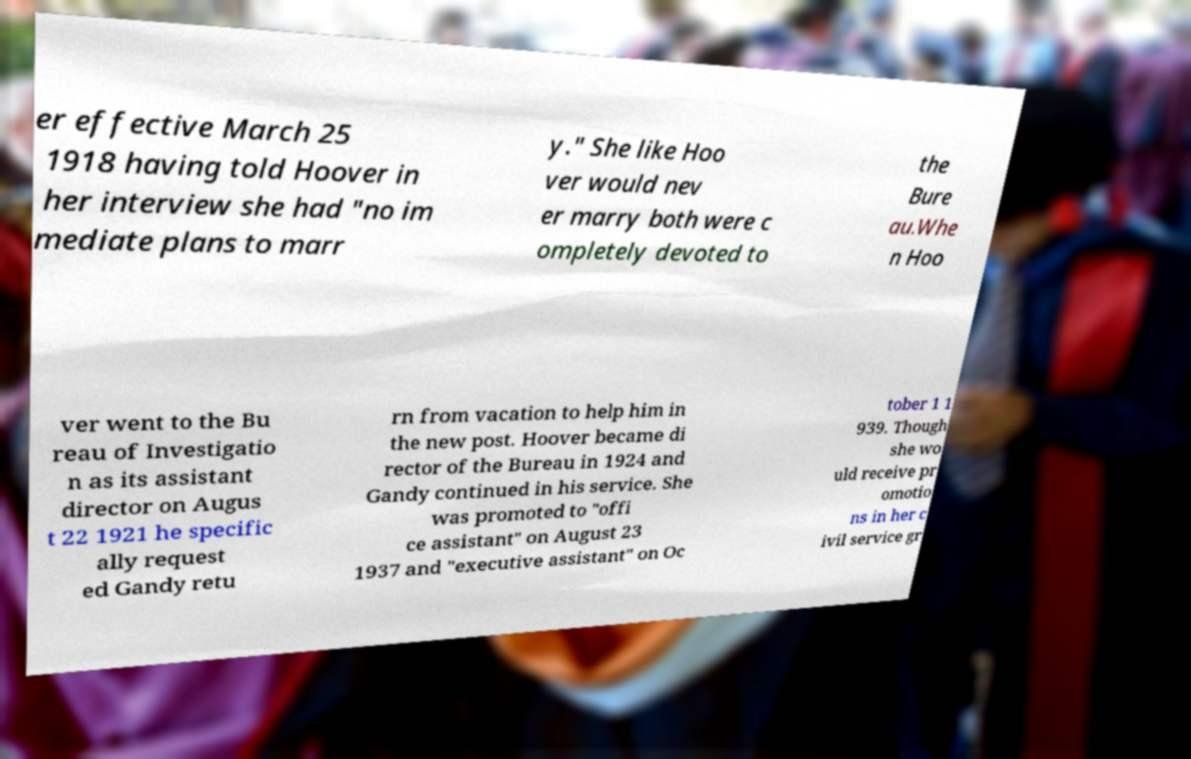What messages or text are displayed in this image? I need them in a readable, typed format. er effective March 25 1918 having told Hoover in her interview she had "no im mediate plans to marr y." She like Hoo ver would nev er marry both were c ompletely devoted to the Bure au.Whe n Hoo ver went to the Bu reau of Investigatio n as its assistant director on Augus t 22 1921 he specific ally request ed Gandy retu rn from vacation to help him in the new post. Hoover became di rector of the Bureau in 1924 and Gandy continued in his service. She was promoted to "offi ce assistant" on August 23 1937 and "executive assistant" on Oc tober 1 1 939. Though she wo uld receive pr omotio ns in her c ivil service gr 